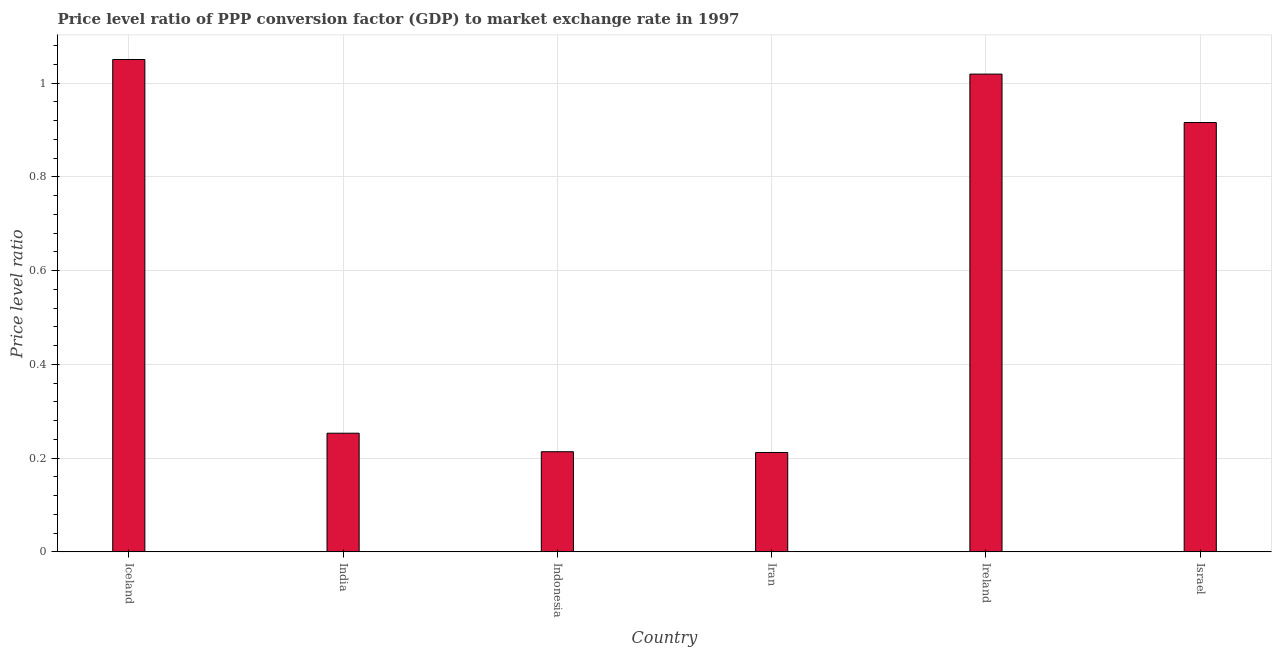What is the title of the graph?
Your response must be concise. Price level ratio of PPP conversion factor (GDP) to market exchange rate in 1997. What is the label or title of the X-axis?
Offer a terse response. Country. What is the label or title of the Y-axis?
Provide a short and direct response. Price level ratio. What is the price level ratio in Israel?
Your response must be concise. 0.92. Across all countries, what is the maximum price level ratio?
Your answer should be compact. 1.05. Across all countries, what is the minimum price level ratio?
Your answer should be very brief. 0.21. In which country was the price level ratio maximum?
Offer a terse response. Iceland. In which country was the price level ratio minimum?
Offer a terse response. Iran. What is the sum of the price level ratio?
Give a very brief answer. 3.67. What is the difference between the price level ratio in Iceland and India?
Offer a very short reply. 0.8. What is the average price level ratio per country?
Make the answer very short. 0.61. What is the median price level ratio?
Keep it short and to the point. 0.58. What is the ratio of the price level ratio in Iceland to that in India?
Keep it short and to the point. 4.15. Is the price level ratio in India less than that in Indonesia?
Offer a very short reply. No. What is the difference between the highest and the second highest price level ratio?
Provide a short and direct response. 0.03. Is the sum of the price level ratio in Iceland and Ireland greater than the maximum price level ratio across all countries?
Ensure brevity in your answer.  Yes. What is the difference between the highest and the lowest price level ratio?
Offer a very short reply. 0.84. How many bars are there?
Your response must be concise. 6. Are all the bars in the graph horizontal?
Your response must be concise. No. How many countries are there in the graph?
Offer a terse response. 6. What is the difference between two consecutive major ticks on the Y-axis?
Keep it short and to the point. 0.2. What is the Price level ratio of Iceland?
Ensure brevity in your answer.  1.05. What is the Price level ratio of India?
Keep it short and to the point. 0.25. What is the Price level ratio of Indonesia?
Offer a very short reply. 0.21. What is the Price level ratio in Iran?
Keep it short and to the point. 0.21. What is the Price level ratio in Ireland?
Your answer should be very brief. 1.02. What is the Price level ratio in Israel?
Keep it short and to the point. 0.92. What is the difference between the Price level ratio in Iceland and India?
Give a very brief answer. 0.8. What is the difference between the Price level ratio in Iceland and Indonesia?
Offer a very short reply. 0.84. What is the difference between the Price level ratio in Iceland and Iran?
Ensure brevity in your answer.  0.84. What is the difference between the Price level ratio in Iceland and Ireland?
Give a very brief answer. 0.03. What is the difference between the Price level ratio in Iceland and Israel?
Offer a very short reply. 0.13. What is the difference between the Price level ratio in India and Indonesia?
Ensure brevity in your answer.  0.04. What is the difference between the Price level ratio in India and Iran?
Your response must be concise. 0.04. What is the difference between the Price level ratio in India and Ireland?
Your answer should be very brief. -0.77. What is the difference between the Price level ratio in India and Israel?
Make the answer very short. -0.66. What is the difference between the Price level ratio in Indonesia and Iran?
Make the answer very short. 0. What is the difference between the Price level ratio in Indonesia and Ireland?
Make the answer very short. -0.81. What is the difference between the Price level ratio in Indonesia and Israel?
Give a very brief answer. -0.7. What is the difference between the Price level ratio in Iran and Ireland?
Provide a succinct answer. -0.81. What is the difference between the Price level ratio in Iran and Israel?
Provide a succinct answer. -0.7. What is the difference between the Price level ratio in Ireland and Israel?
Your answer should be very brief. 0.1. What is the ratio of the Price level ratio in Iceland to that in India?
Your answer should be compact. 4.15. What is the ratio of the Price level ratio in Iceland to that in Indonesia?
Make the answer very short. 4.92. What is the ratio of the Price level ratio in Iceland to that in Iran?
Your answer should be very brief. 4.95. What is the ratio of the Price level ratio in Iceland to that in Ireland?
Make the answer very short. 1.03. What is the ratio of the Price level ratio in Iceland to that in Israel?
Your answer should be very brief. 1.15. What is the ratio of the Price level ratio in India to that in Indonesia?
Ensure brevity in your answer.  1.19. What is the ratio of the Price level ratio in India to that in Iran?
Your answer should be compact. 1.19. What is the ratio of the Price level ratio in India to that in Ireland?
Ensure brevity in your answer.  0.25. What is the ratio of the Price level ratio in India to that in Israel?
Your answer should be very brief. 0.28. What is the ratio of the Price level ratio in Indonesia to that in Iran?
Ensure brevity in your answer.  1.01. What is the ratio of the Price level ratio in Indonesia to that in Ireland?
Keep it short and to the point. 0.21. What is the ratio of the Price level ratio in Indonesia to that in Israel?
Keep it short and to the point. 0.23. What is the ratio of the Price level ratio in Iran to that in Ireland?
Provide a short and direct response. 0.21. What is the ratio of the Price level ratio in Iran to that in Israel?
Provide a short and direct response. 0.23. What is the ratio of the Price level ratio in Ireland to that in Israel?
Your answer should be very brief. 1.11. 